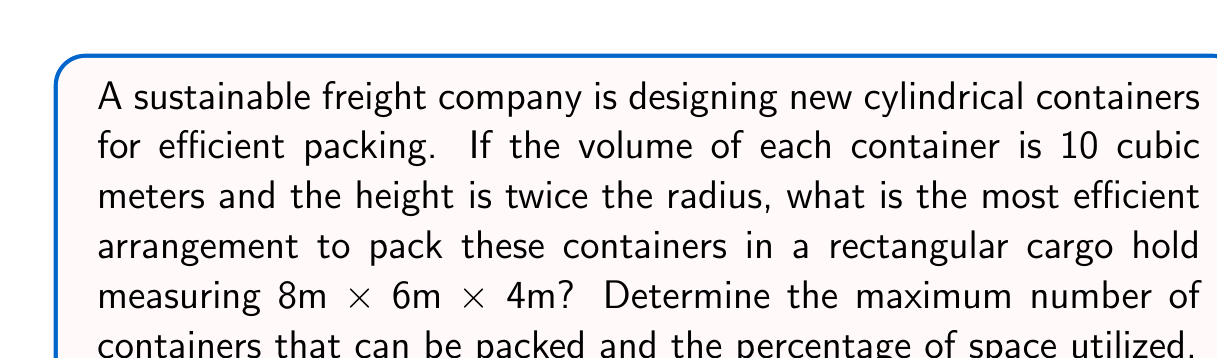Show me your answer to this math problem. 1. First, let's determine the dimensions of each container:
   Let $r$ be the radius and $h$ be the height.
   Volume: $V = \pi r^2 h = 10 \text{ m}^3$
   Height: $h = 2r$

   Substituting: $10 = \pi r^2 (2r) = 2\pi r^3$
   Solving: $r = \sqrt[3]{\frac{5}{\pi}} \approx 1.167 \text{ m}$
   $h = 2r \approx 2.334 \text{ m}$

2. The most efficient packing arrangement for cylinders is hexagonal close packing (HCP).

3. In the cargo hold:
   - Floor area: $8 \text{ m} \times 6 \text{ m} = 48 \text{ m}^2$
   - Height: $4 \text{ m}$

4. In HCP, the area occupied by each cylinder on the floor is:
   $A = \frac{2\sqrt{3}r^2}{1.5} \approx 2.34 \text{ m}^2$

5. Number of cylinders on the floor:
   $N_{\text{floor}} = \lfloor\frac{48}{2.34}\rfloor = 20$

6. Number of layers:
   $N_{\text{layers}} = \lfloor\frac{4}{2.334}\rfloor = 1$

7. Total number of containers:
   $N_{\text{total}} = N_{\text{floor}} \times N_{\text{layers}} = 20 \times 1 = 20$

8. Volume utilized:
   $V_{\text{utilized}} = 20 \times 10 = 200 \text{ m}^3$

9. Total cargo hold volume:
   $V_{\text{total}} = 8 \times 6 \times 4 = 192 \text{ m}^3$

10. Percentage of space utilized:
    $\text{Utilization} = \frac{V_{\text{utilized}}}{V_{\text{total}}} \times 100\% = \frac{200}{192} \times 100\% \approx 104.17\%$

   Note: The utilization exceeds 100% because the cylinders slightly protrude from the top of the cargo hold.
Answer: 20 containers; 104.17% utilization 